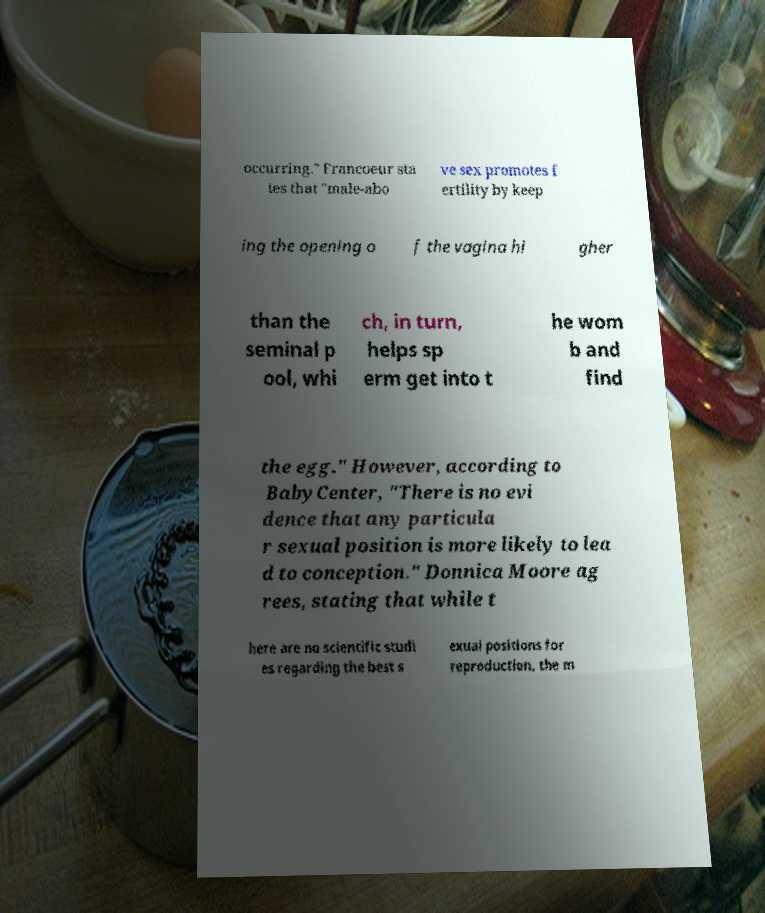Please identify and transcribe the text found in this image. occurring." Francoeur sta tes that "male-abo ve sex promotes f ertility by keep ing the opening o f the vagina hi gher than the seminal p ool, whi ch, in turn, helps sp erm get into t he wom b and find the egg." However, according to BabyCenter, "There is no evi dence that any particula r sexual position is more likely to lea d to conception." Donnica Moore ag rees, stating that while t here are no scientific studi es regarding the best s exual positions for reproduction, the m 